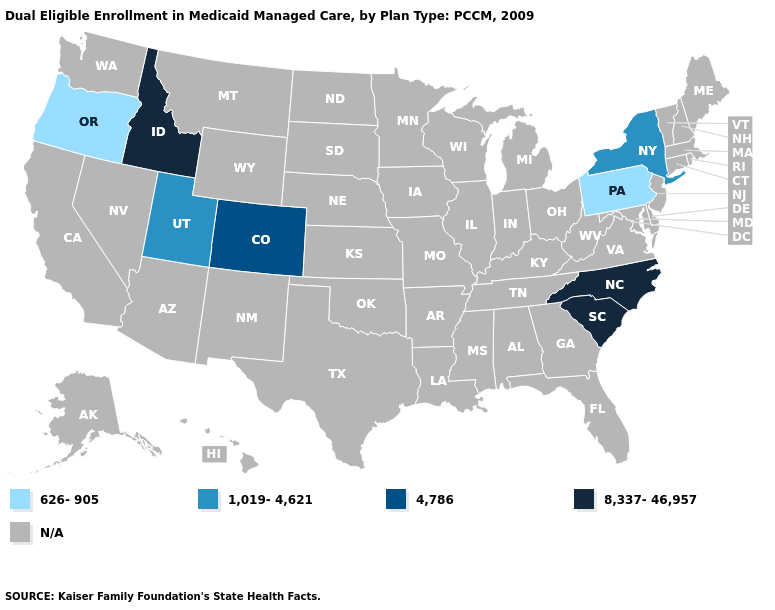What is the value of Arkansas?
Give a very brief answer. N/A. What is the lowest value in states that border Nebraska?
Keep it brief. 4,786. Is the legend a continuous bar?
Keep it brief. No. Name the states that have a value in the range 1,019-4,621?
Write a very short answer. New York, Utah. Does the first symbol in the legend represent the smallest category?
Short answer required. Yes. Name the states that have a value in the range 626-905?
Keep it brief. Oregon, Pennsylvania. What is the lowest value in the USA?
Quick response, please. 626-905. Name the states that have a value in the range 8,337-46,957?
Write a very short answer. Idaho, North Carolina, South Carolina. Name the states that have a value in the range 4,786?
Quick response, please. Colorado. Name the states that have a value in the range 8,337-46,957?
Answer briefly. Idaho, North Carolina, South Carolina. What is the lowest value in states that border Colorado?
Keep it brief. 1,019-4,621. 